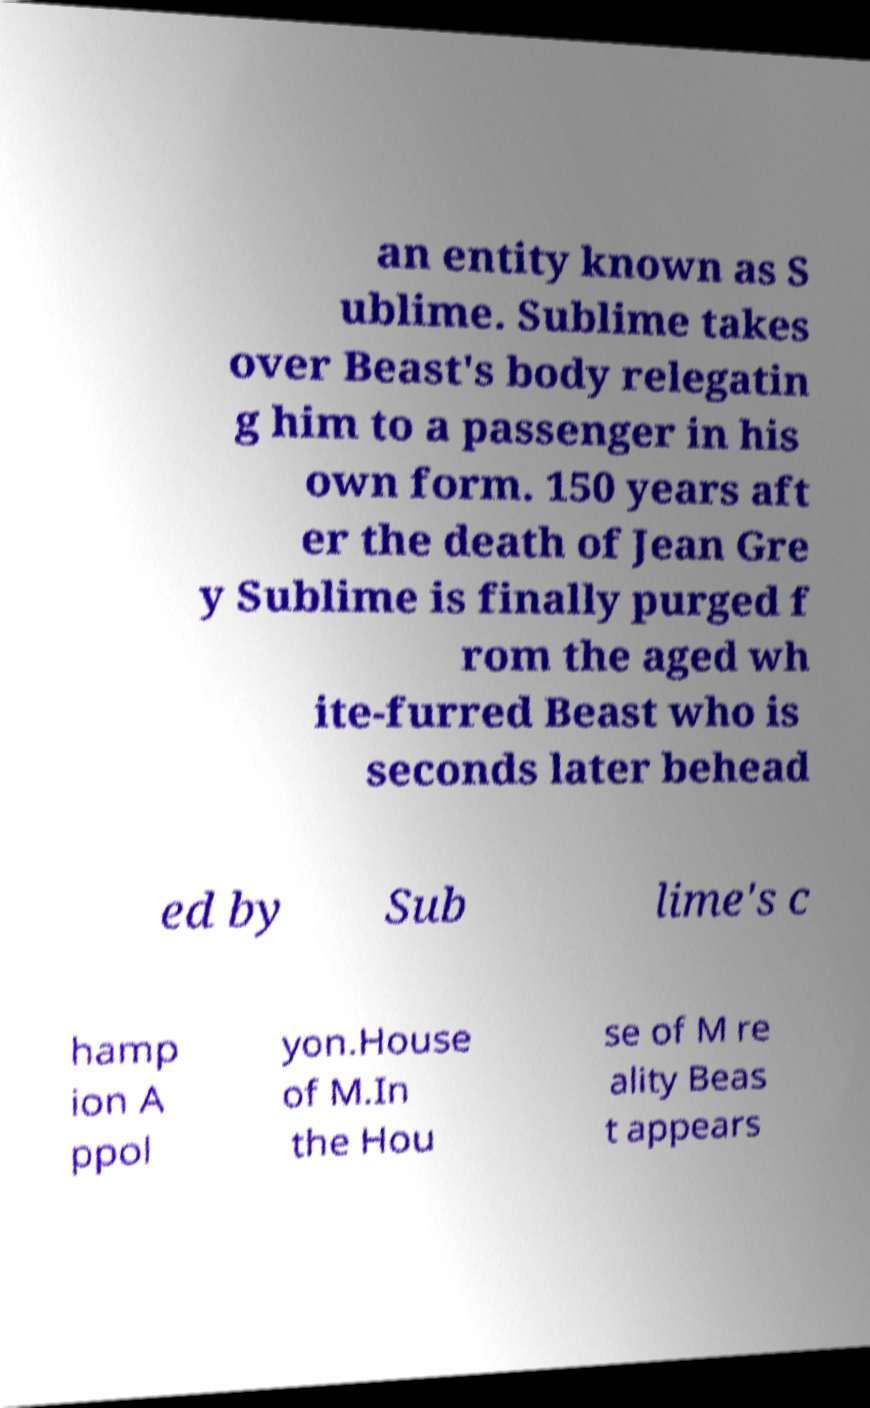Please identify and transcribe the text found in this image. an entity known as S ublime. Sublime takes over Beast's body relegatin g him to a passenger in his own form. 150 years aft er the death of Jean Gre y Sublime is finally purged f rom the aged wh ite-furred Beast who is seconds later behead ed by Sub lime's c hamp ion A ppol yon.House of M.In the Hou se of M re ality Beas t appears 